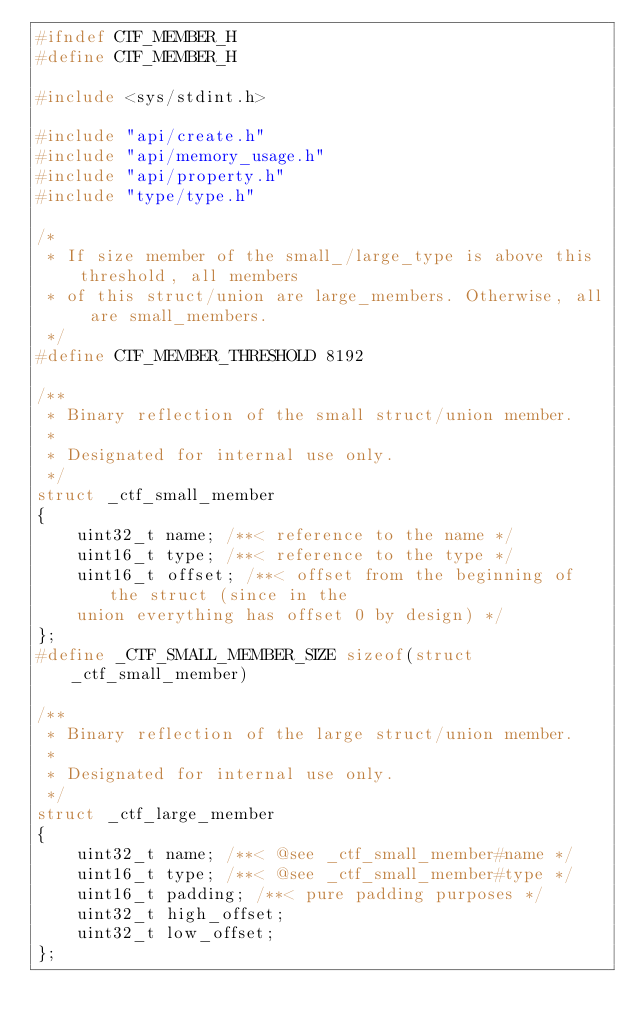Convert code to text. <code><loc_0><loc_0><loc_500><loc_500><_C_>#ifndef CTF_MEMBER_H
#define CTF_MEMBER_H

#include <sys/stdint.h>

#include "api/create.h"
#include "api/memory_usage.h"
#include "api/property.h"
#include "type/type.h"

/* 
 * If size member of the small_/large_type is above this threshold, all members
 * of this struct/union are large_members. Otherwise, all are small_members.
 */
#define CTF_MEMBER_THRESHOLD 8192

/**
 * Binary reflection of the small struct/union member.
 *
 * Designated for internal use only.
 */
struct _ctf_small_member
{
	uint32_t name; /**< reference to the name */
	uint16_t type; /**< reference to the type */
	uint16_t offset; /**< offset from the beginning of the struct (since in the
	union everything has offset 0 by design) */
};
#define _CTF_SMALL_MEMBER_SIZE sizeof(struct _ctf_small_member)

/**
 * Binary reflection of the large struct/union member.
 *
 * Designated for internal use only.
 */
struct _ctf_large_member
{
	uint32_t name; /**< @see _ctf_small_member#name */
	uint16_t type; /**< @see _ctf_small_member#type */
	uint16_t padding; /**< pure padding purposes */
	uint32_t high_offset;
	uint32_t low_offset;
};</code> 